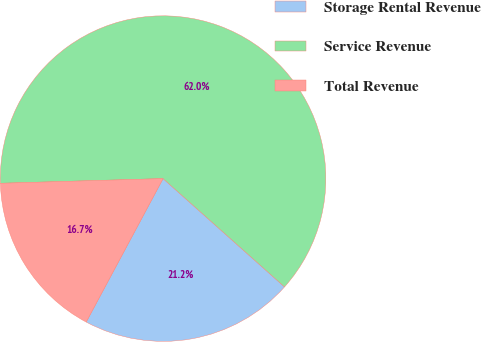Convert chart to OTSL. <chart><loc_0><loc_0><loc_500><loc_500><pie_chart><fcel>Storage Rental Revenue<fcel>Service Revenue<fcel>Total Revenue<nl><fcel>21.24%<fcel>62.05%<fcel>16.71%<nl></chart> 